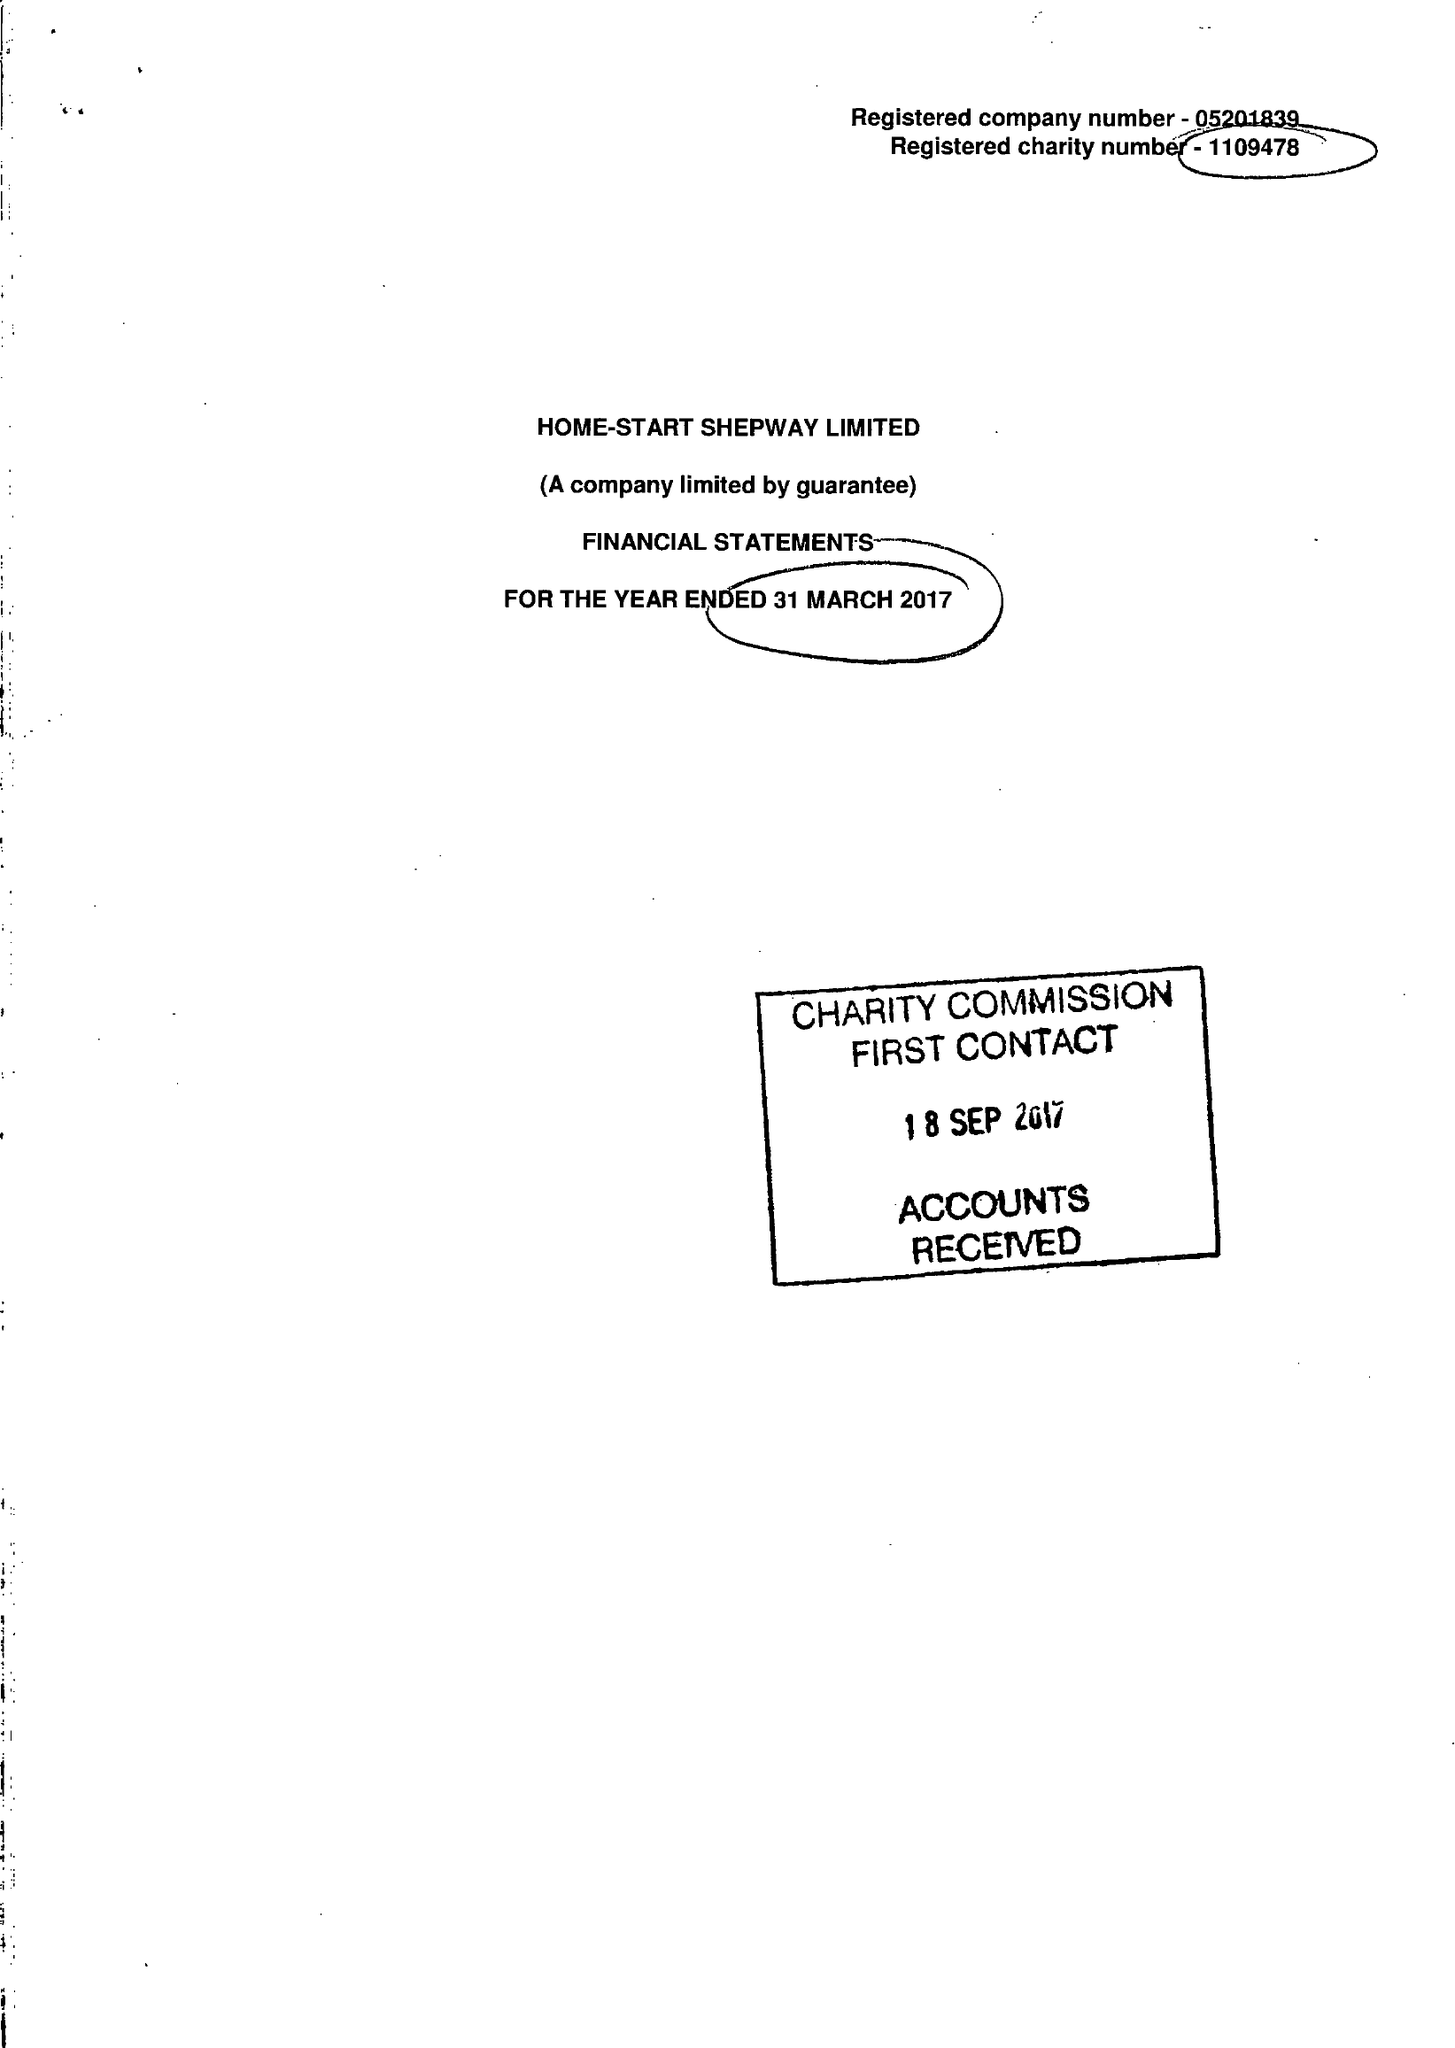What is the value for the charity_number?
Answer the question using a single word or phrase. 1109478 